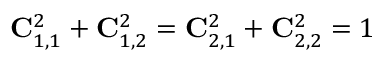Convert formula to latex. <formula><loc_0><loc_0><loc_500><loc_500>{ C } _ { 1 , 1 } ^ { 2 } + { C } _ { 1 , 2 } ^ { 2 } = { C } _ { 2 , 1 } ^ { 2 } + { C } _ { 2 , 2 } ^ { 2 } = 1</formula> 